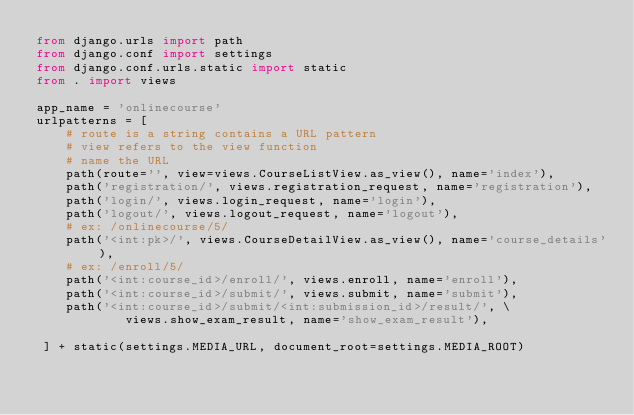<code> <loc_0><loc_0><loc_500><loc_500><_Python_>from django.urls import path
from django.conf import settings
from django.conf.urls.static import static
from . import views

app_name = 'onlinecourse'
urlpatterns = [
    # route is a string contains a URL pattern
    # view refers to the view function
    # name the URL
    path(route='', view=views.CourseListView.as_view(), name='index'),
    path('registration/', views.registration_request, name='registration'),
    path('login/', views.login_request, name='login'),
    path('logout/', views.logout_request, name='logout'),
    # ex: /onlinecourse/5/
    path('<int:pk>/', views.CourseDetailView.as_view(), name='course_details'),
    # ex: /enroll/5/
    path('<int:course_id>/enroll/', views.enroll, name='enroll'),
    path('<int:course_id>/submit/', views.submit, name='submit'),
    path('<int:course_id>/submit/<int:submission_id>/result/', \
            views.show_exam_result, name='show_exam_result'),

 ] + static(settings.MEDIA_URL, document_root=settings.MEDIA_ROOT)
</code> 